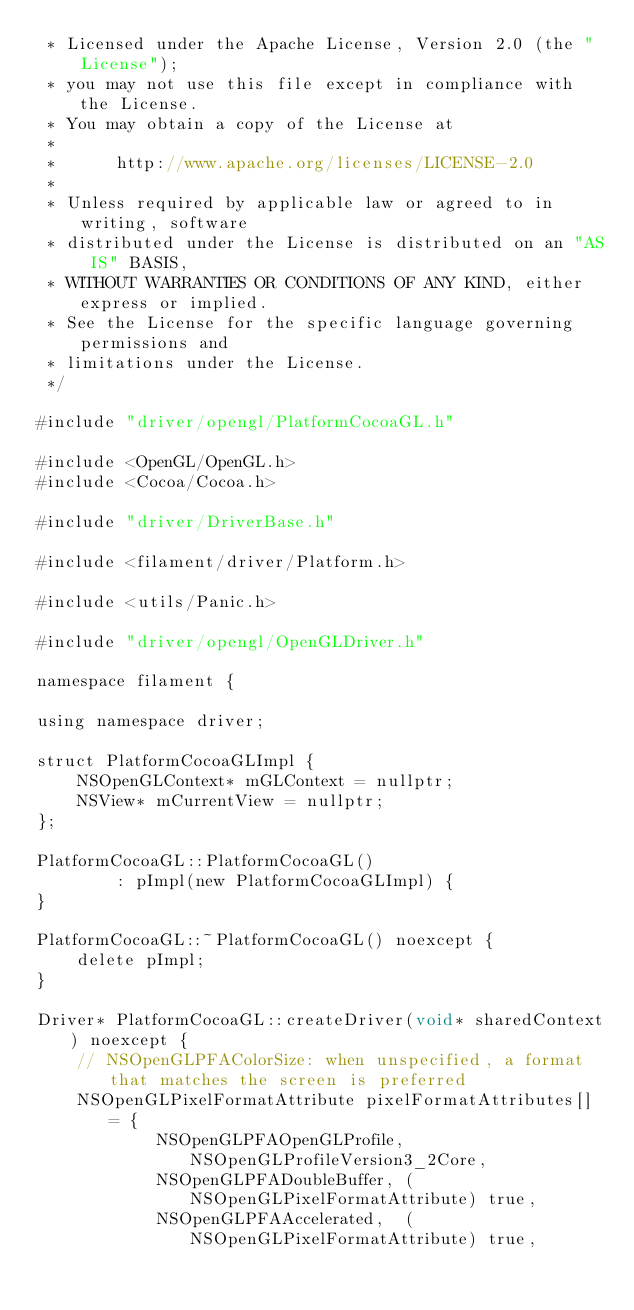Convert code to text. <code><loc_0><loc_0><loc_500><loc_500><_ObjectiveC_> * Licensed under the Apache License, Version 2.0 (the "License");
 * you may not use this file except in compliance with the License.
 * You may obtain a copy of the License at
 *
 *      http://www.apache.org/licenses/LICENSE-2.0
 *
 * Unless required by applicable law or agreed to in writing, software
 * distributed under the License is distributed on an "AS IS" BASIS,
 * WITHOUT WARRANTIES OR CONDITIONS OF ANY KIND, either express or implied.
 * See the License for the specific language governing permissions and
 * limitations under the License.
 */

#include "driver/opengl/PlatformCocoaGL.h"

#include <OpenGL/OpenGL.h>
#include <Cocoa/Cocoa.h>

#include "driver/DriverBase.h"

#include <filament/driver/Platform.h>

#include <utils/Panic.h>

#include "driver/opengl/OpenGLDriver.h"

namespace filament {

using namespace driver;

struct PlatformCocoaGLImpl {
    NSOpenGLContext* mGLContext = nullptr;
    NSView* mCurrentView = nullptr;
};

PlatformCocoaGL::PlatformCocoaGL()
        : pImpl(new PlatformCocoaGLImpl) {
}

PlatformCocoaGL::~PlatformCocoaGL() noexcept {
    delete pImpl;
}

Driver* PlatformCocoaGL::createDriver(void* sharedContext) noexcept {
    // NSOpenGLPFAColorSize: when unspecified, a format that matches the screen is preferred
    NSOpenGLPixelFormatAttribute pixelFormatAttributes[] = {
            NSOpenGLPFAOpenGLProfile, NSOpenGLProfileVersion3_2Core,
            NSOpenGLPFADoubleBuffer, (NSOpenGLPixelFormatAttribute) true,
            NSOpenGLPFAAccelerated,  (NSOpenGLPixelFormatAttribute) true,</code> 